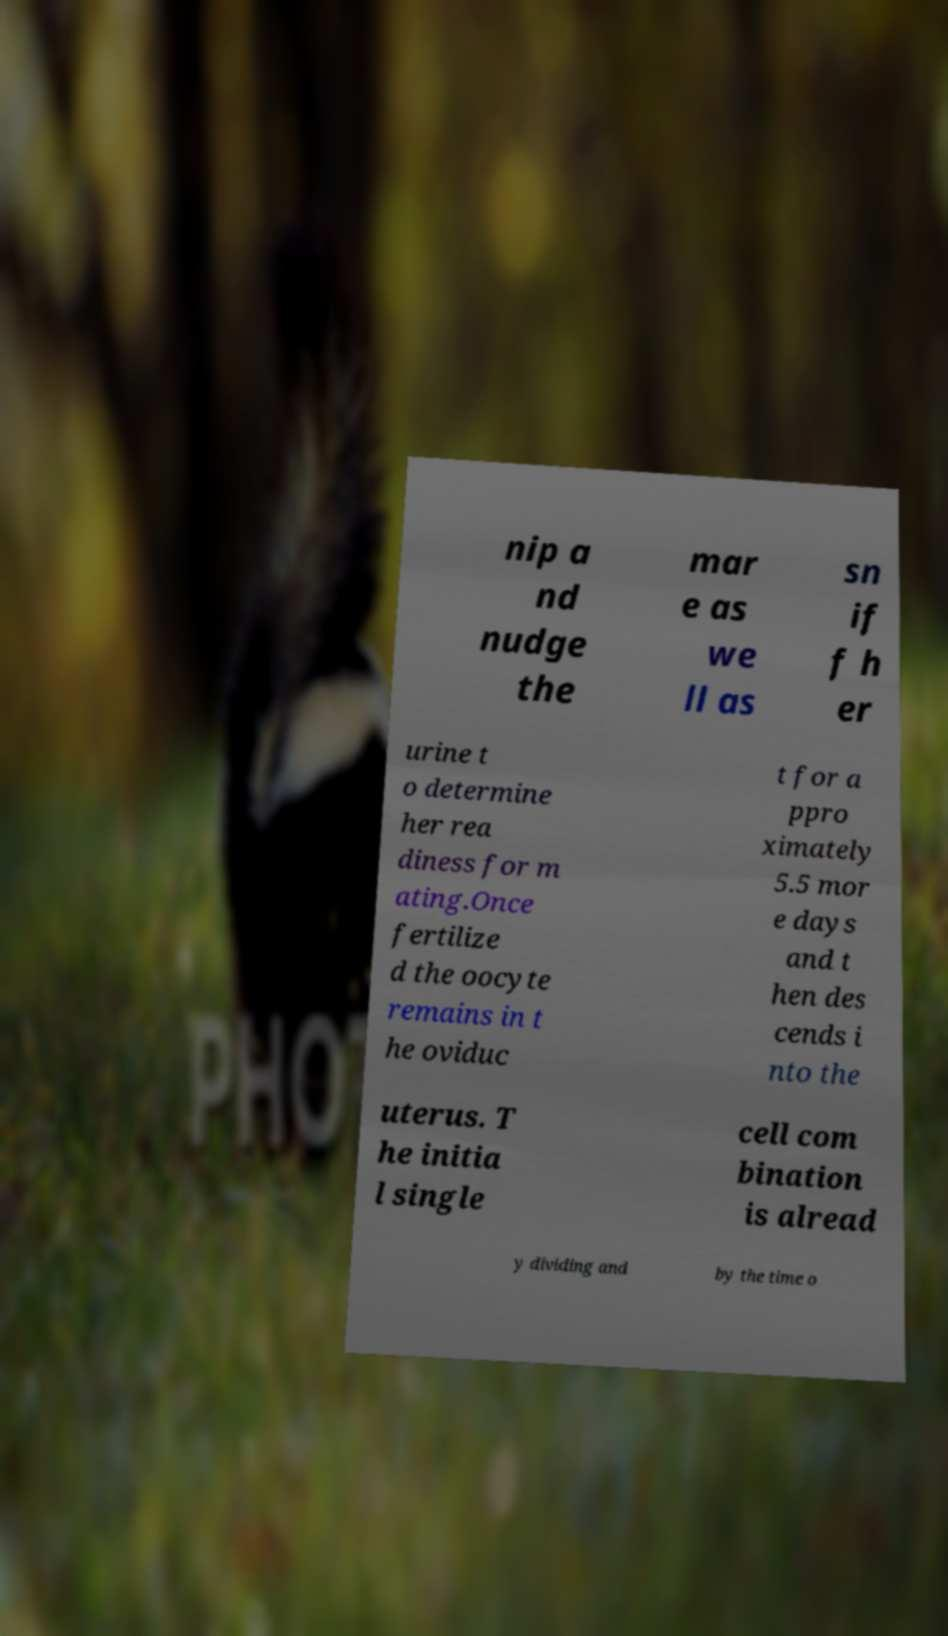Could you assist in decoding the text presented in this image and type it out clearly? nip a nd nudge the mar e as we ll as sn if f h er urine t o determine her rea diness for m ating.Once fertilize d the oocyte remains in t he oviduc t for a ppro ximately 5.5 mor e days and t hen des cends i nto the uterus. T he initia l single cell com bination is alread y dividing and by the time o 